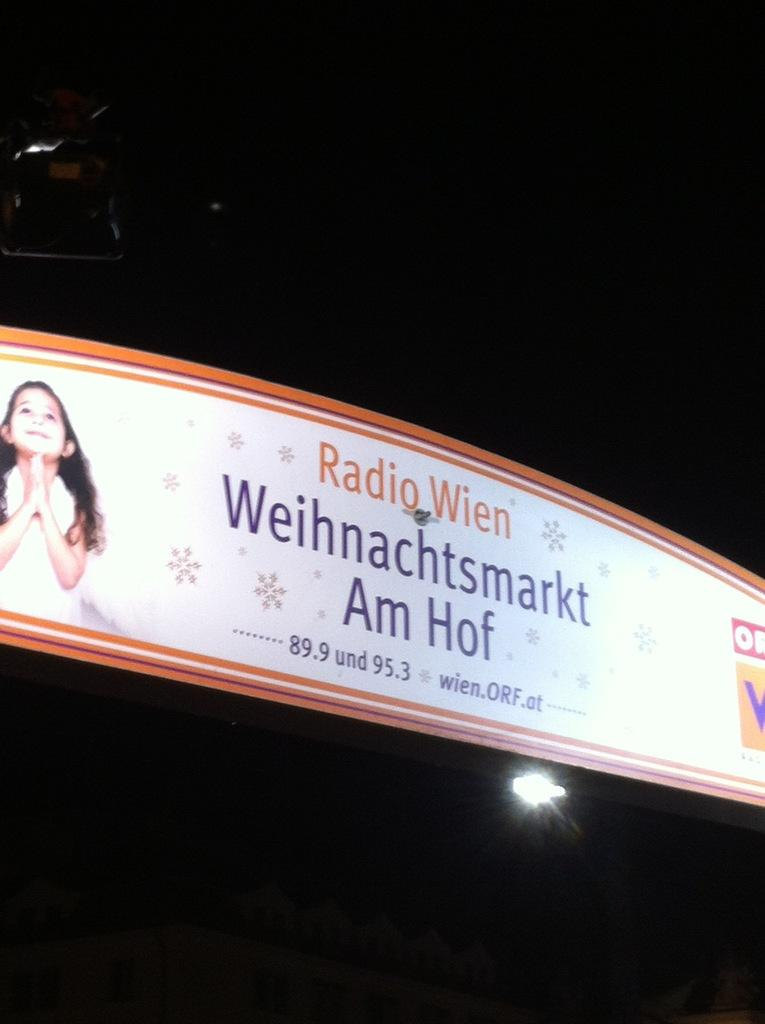How does the adjustment of the match affect the low temperature in the image? There is no image, and therefore no match or temperature to adjust. 